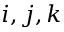<formula> <loc_0><loc_0><loc_500><loc_500>i , j , k</formula> 